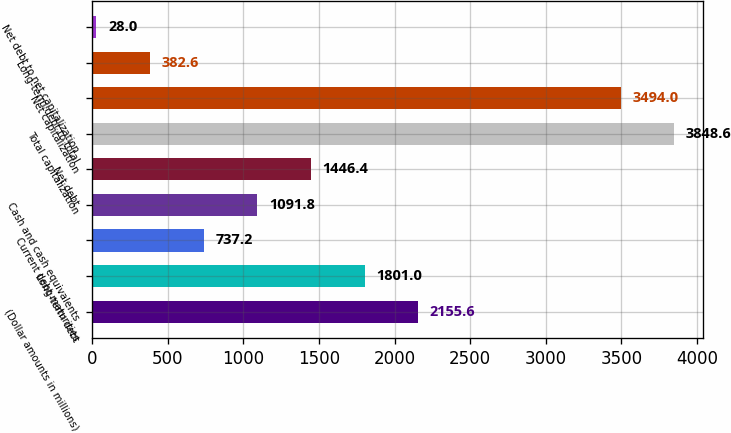Convert chart to OTSL. <chart><loc_0><loc_0><loc_500><loc_500><bar_chart><fcel>(Dollar amounts in millions)<fcel>Long-term debt<fcel>Current debt maturities<fcel>Cash and cash equivalents<fcel>Net debt<fcel>Total capitalization<fcel>Net capitalization<fcel>Long-term debt to total<fcel>Net debt to net capitalization<nl><fcel>2155.6<fcel>1801<fcel>737.2<fcel>1091.8<fcel>1446.4<fcel>3848.6<fcel>3494<fcel>382.6<fcel>28<nl></chart> 